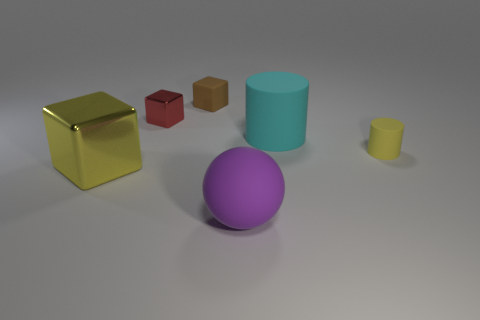Is the number of large cylinders that are behind the small yellow matte thing less than the number of tiny blocks?
Give a very brief answer. Yes. What number of yellow shiny things are the same size as the brown object?
Your answer should be very brief. 0. What shape is the big metallic thing that is the same color as the tiny cylinder?
Your answer should be very brief. Cube. Do the shiny cube that is to the left of the small red metallic block and the tiny matte thing that is in front of the brown matte cube have the same color?
Keep it short and to the point. Yes. There is a large shiny thing; what number of things are in front of it?
Ensure brevity in your answer.  1. There is a shiny object that is the same color as the small cylinder; what is its size?
Your response must be concise. Large. Are there any red metal objects that have the same shape as the purple thing?
Make the answer very short. No. What color is the rubber block that is the same size as the red object?
Offer a terse response. Brown. Is the number of yellow matte cylinders that are behind the small red shiny cube less than the number of cyan cylinders behind the cyan object?
Give a very brief answer. No. Do the yellow thing right of the matte cube and the red metallic object have the same size?
Offer a very short reply. Yes. 